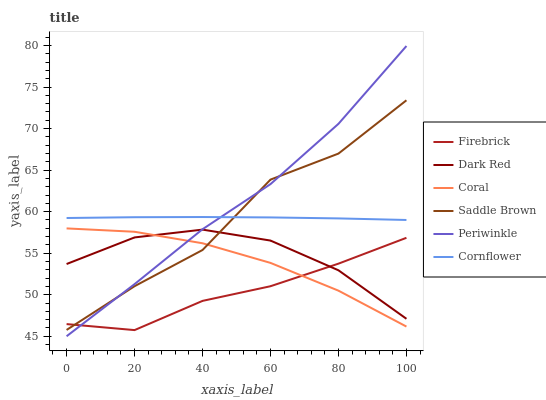Does Firebrick have the minimum area under the curve?
Answer yes or no. Yes. Does Periwinkle have the maximum area under the curve?
Answer yes or no. Yes. Does Dark Red have the minimum area under the curve?
Answer yes or no. No. Does Dark Red have the maximum area under the curve?
Answer yes or no. No. Is Cornflower the smoothest?
Answer yes or no. Yes. Is Saddle Brown the roughest?
Answer yes or no. Yes. Is Dark Red the smoothest?
Answer yes or no. No. Is Dark Red the roughest?
Answer yes or no. No. Does Periwinkle have the lowest value?
Answer yes or no. Yes. Does Dark Red have the lowest value?
Answer yes or no. No. Does Periwinkle have the highest value?
Answer yes or no. Yes. Does Dark Red have the highest value?
Answer yes or no. No. Is Firebrick less than Cornflower?
Answer yes or no. Yes. Is Cornflower greater than Dark Red?
Answer yes or no. Yes. Does Dark Red intersect Periwinkle?
Answer yes or no. Yes. Is Dark Red less than Periwinkle?
Answer yes or no. No. Is Dark Red greater than Periwinkle?
Answer yes or no. No. Does Firebrick intersect Cornflower?
Answer yes or no. No. 